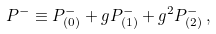<formula> <loc_0><loc_0><loc_500><loc_500>P ^ { - } \equiv P ^ { - } _ { ( 0 ) } + g P ^ { - } _ { ( 1 ) } + g ^ { 2 } P ^ { - } _ { ( 2 ) } \, ,</formula> 